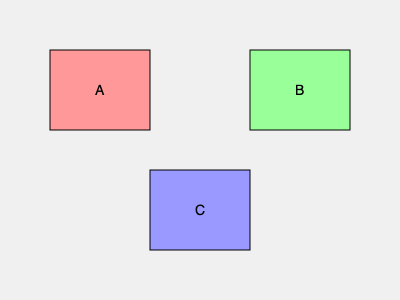You have three paintings of different sizes and colors (A, B, and C) to arrange on your wall. To create a balanced composition, you decide to place two paintings at the top and one at the bottom. If the visual weight of painting A is 3 units, B is 4 units, and C is 5 units, which arrangement would create the most balanced composition? To determine the most balanced composition, we need to consider the visual weight distribution:

1. Calculate the total visual weight: $3 + 4 + 5 = 12$ units

2. For perfect balance, we want the top row to have half the total weight: $12 \div 2 = 6$ units

3. Examine possible arrangements:
   a) A and B on top: $3 + 4 = 7$ units (top), $5$ units (bottom)
   b) A and C on top: $3 + 5 = 8$ units (top), $4$ units (bottom)
   c) B and C on top: $4 + 5 = 9$ units (top), $3$ units (bottom)

4. Calculate the difference from ideal balance for each arrangement:
   a) $|7 - 6| + |5 - 6| = 2$ units off
   b) $|8 - 6| + |4 - 6| = 4$ units off
   c) $|9 - 6| + |3 - 6| = 6$ units off

5. The arrangement with the smallest difference from ideal balance is the most balanced composition.

Therefore, the most balanced composition is arrangement (a), with paintings A and B on top and C at the bottom.
Answer: A and B on top, C at the bottom 